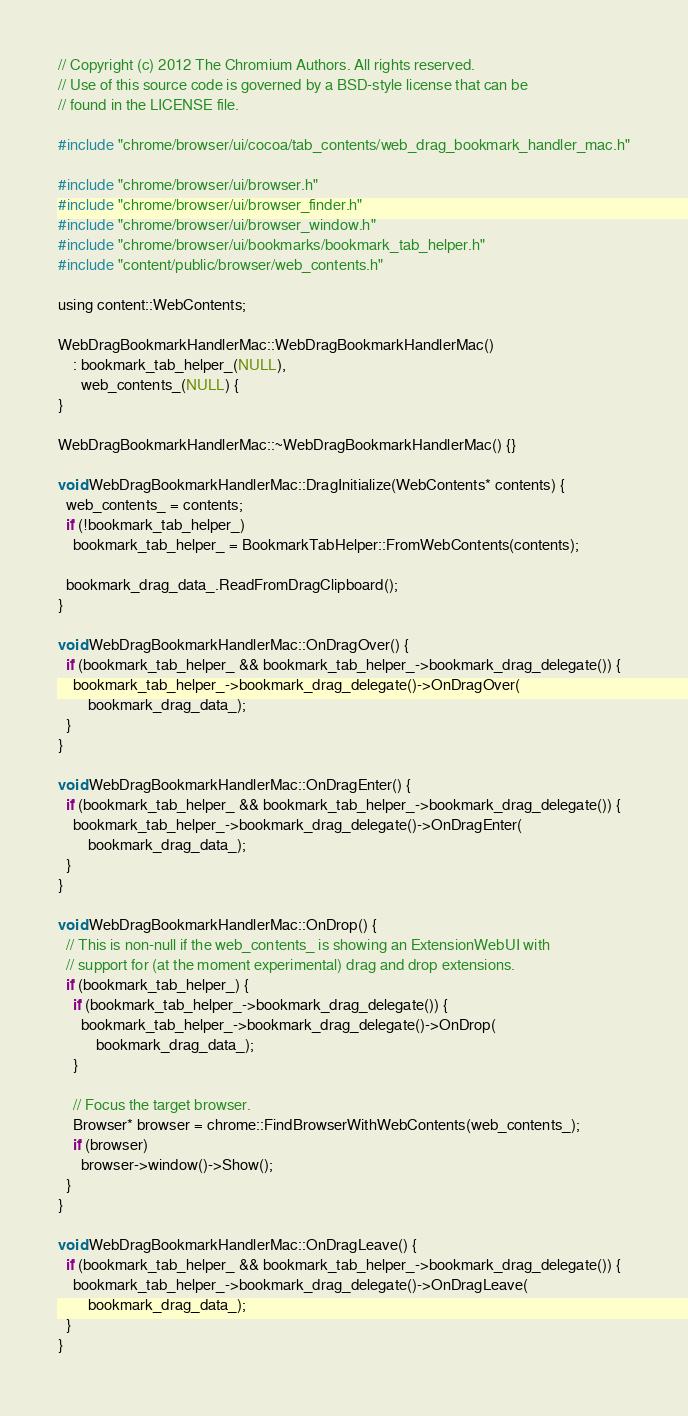<code> <loc_0><loc_0><loc_500><loc_500><_ObjectiveC_>// Copyright (c) 2012 The Chromium Authors. All rights reserved.
// Use of this source code is governed by a BSD-style license that can be
// found in the LICENSE file.

#include "chrome/browser/ui/cocoa/tab_contents/web_drag_bookmark_handler_mac.h"

#include "chrome/browser/ui/browser.h"
#include "chrome/browser/ui/browser_finder.h"
#include "chrome/browser/ui/browser_window.h"
#include "chrome/browser/ui/bookmarks/bookmark_tab_helper.h"
#include "content/public/browser/web_contents.h"

using content::WebContents;

WebDragBookmarkHandlerMac::WebDragBookmarkHandlerMac()
    : bookmark_tab_helper_(NULL),
      web_contents_(NULL) {
}

WebDragBookmarkHandlerMac::~WebDragBookmarkHandlerMac() {}

void WebDragBookmarkHandlerMac::DragInitialize(WebContents* contents) {
  web_contents_ = contents;
  if (!bookmark_tab_helper_)
    bookmark_tab_helper_ = BookmarkTabHelper::FromWebContents(contents);

  bookmark_drag_data_.ReadFromDragClipboard();
}

void WebDragBookmarkHandlerMac::OnDragOver() {
  if (bookmark_tab_helper_ && bookmark_tab_helper_->bookmark_drag_delegate()) {
    bookmark_tab_helper_->bookmark_drag_delegate()->OnDragOver(
        bookmark_drag_data_);
  }
}

void WebDragBookmarkHandlerMac::OnDragEnter() {
  if (bookmark_tab_helper_ && bookmark_tab_helper_->bookmark_drag_delegate()) {
    bookmark_tab_helper_->bookmark_drag_delegate()->OnDragEnter(
        bookmark_drag_data_);
  }
}

void WebDragBookmarkHandlerMac::OnDrop() {
  // This is non-null if the web_contents_ is showing an ExtensionWebUI with
  // support for (at the moment experimental) drag and drop extensions.
  if (bookmark_tab_helper_) {
    if (bookmark_tab_helper_->bookmark_drag_delegate()) {
      bookmark_tab_helper_->bookmark_drag_delegate()->OnDrop(
          bookmark_drag_data_);
    }

    // Focus the target browser.
    Browser* browser = chrome::FindBrowserWithWebContents(web_contents_);
    if (browser)
      browser->window()->Show();
  }
}

void WebDragBookmarkHandlerMac::OnDragLeave() {
  if (bookmark_tab_helper_ && bookmark_tab_helper_->bookmark_drag_delegate()) {
    bookmark_tab_helper_->bookmark_drag_delegate()->OnDragLeave(
        bookmark_drag_data_);
  }
}
</code> 